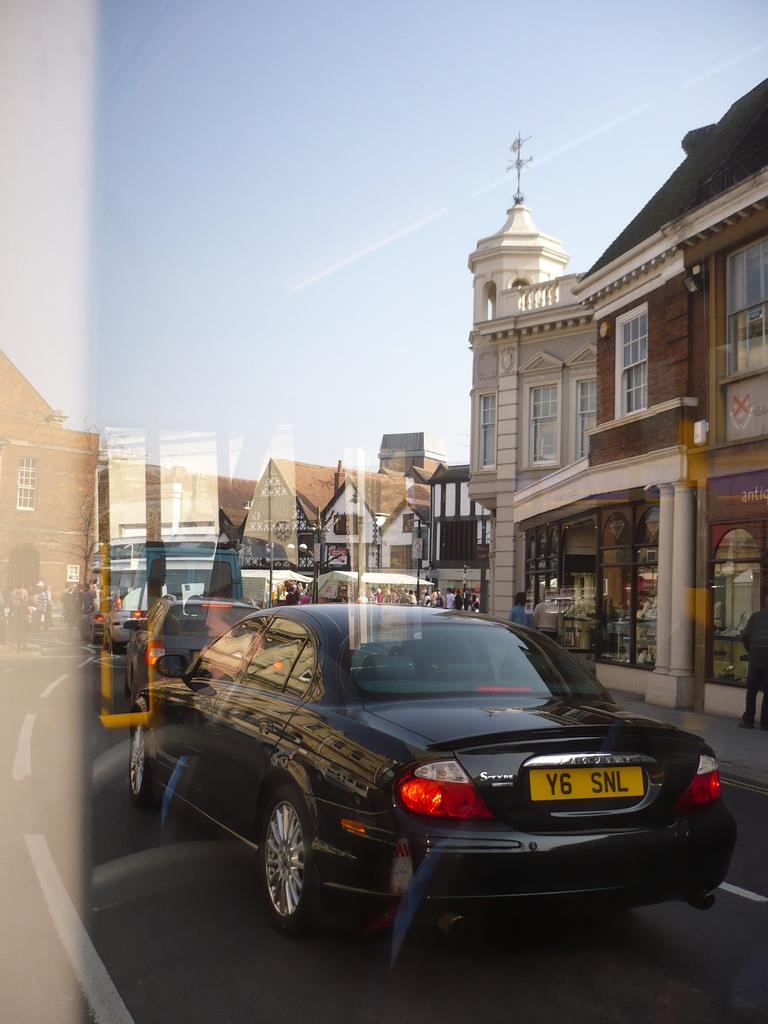What is the main feature of the image? There is a road in the image. What is happening on the road? There are vehicles on the road. What else can be seen in the image besides the road and vehicles? There are buildings and people in the image. What can be seen in the background of the image? The sky is visible in the background of the image. Can you tell me how many doctors are present in the image? There is no doctor present in the image; it features a road, vehicles, buildings, and people. What type of action is the tree performing in the image? There is no tree present in the image, so it cannot perform any actions. 